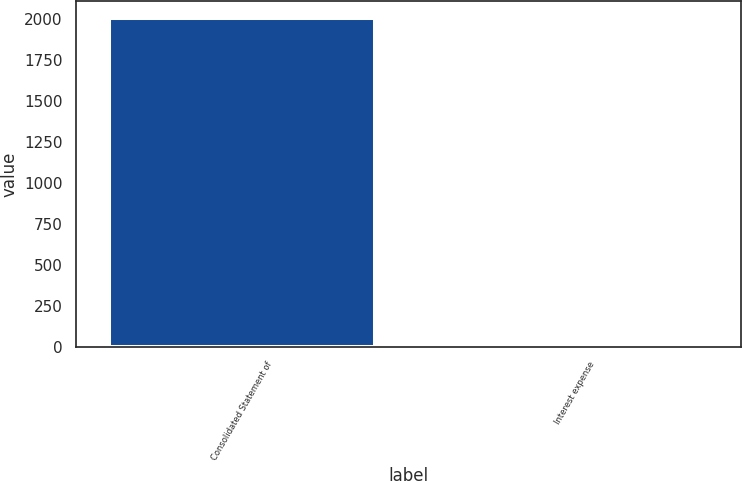Convert chart. <chart><loc_0><loc_0><loc_500><loc_500><bar_chart><fcel>Consolidated Statement of<fcel>Interest expense<nl><fcel>2008<fcel>3.8<nl></chart> 